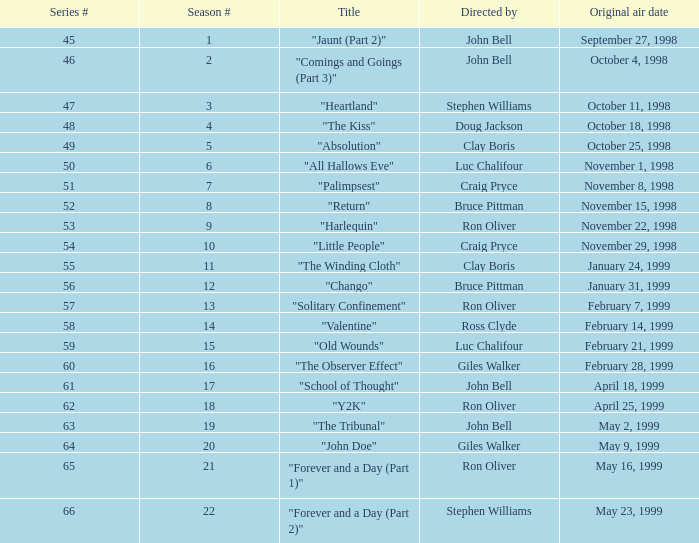What is the original air date of the episode titled "palimpsest" that belongs to a season with a number under 21? November 8, 1998. 